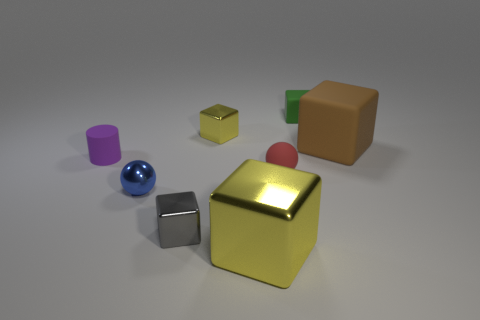Does the large shiny thing have the same color as the tiny metal block behind the small metal sphere?
Your answer should be very brief. Yes. Is the number of matte spheres that are left of the tiny green cube greater than the number of blue cylinders?
Offer a very short reply. Yes. What number of objects are tiny matte things that are to the right of the matte sphere or metallic objects that are to the left of the large yellow metallic thing?
Make the answer very short. 4. What is the size of the other yellow block that is the same material as the small yellow cube?
Give a very brief answer. Large. Do the yellow object that is in front of the purple rubber cylinder and the tiny blue object have the same shape?
Your response must be concise. No. What is the size of the other shiny cube that is the same color as the big metal cube?
Offer a terse response. Small. What number of yellow things are balls or big metal cubes?
Your answer should be compact. 1. What number of other things are there of the same shape as the small yellow shiny thing?
Your response must be concise. 4. The metallic object that is behind the small gray object and in front of the tiny red matte sphere has what shape?
Offer a terse response. Sphere. There is a large brown thing; are there any matte blocks behind it?
Your answer should be compact. Yes. 